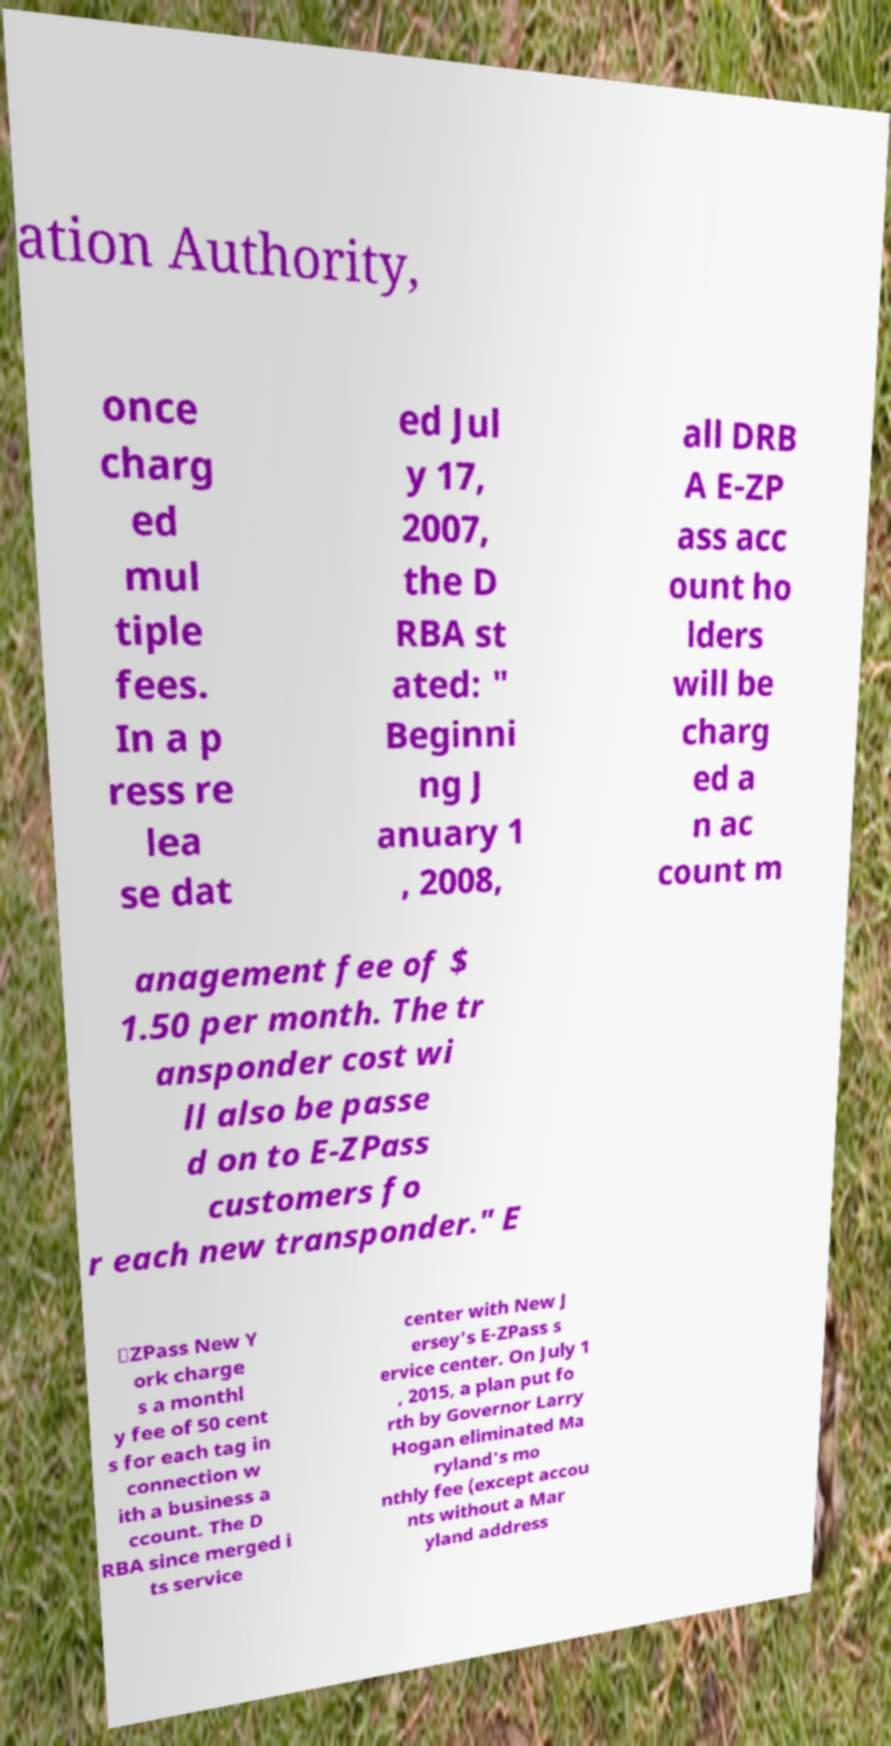There's text embedded in this image that I need extracted. Can you transcribe it verbatim? ation Authority, once charg ed mul tiple fees. In a p ress re lea se dat ed Jul y 17, 2007, the D RBA st ated: " Beginni ng J anuary 1 , 2008, all DRB A E-ZP ass acc ount ho lders will be charg ed a n ac count m anagement fee of $ 1.50 per month. The tr ansponder cost wi ll also be passe d on to E-ZPass customers fo r each new transponder." E ‑ZPass New Y ork charge s a monthl y fee of 50 cent s for each tag in connection w ith a business a ccount. The D RBA since merged i ts service center with New J ersey's E-ZPass s ervice center. On July 1 , 2015, a plan put fo rth by Governor Larry Hogan eliminated Ma ryland's mo nthly fee (except accou nts without a Mar yland address 